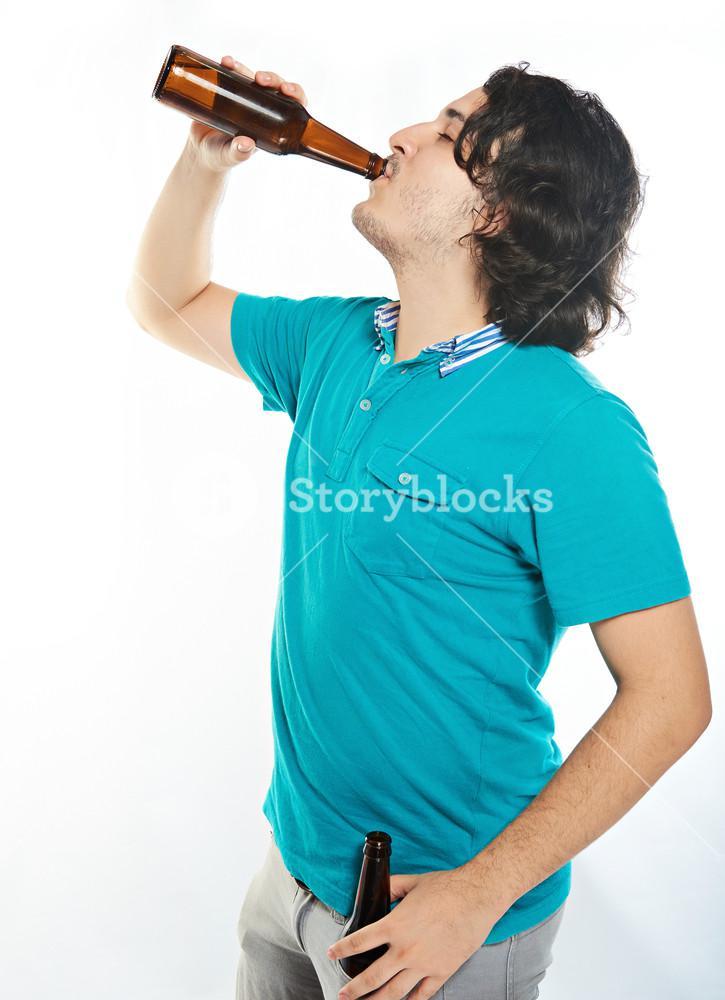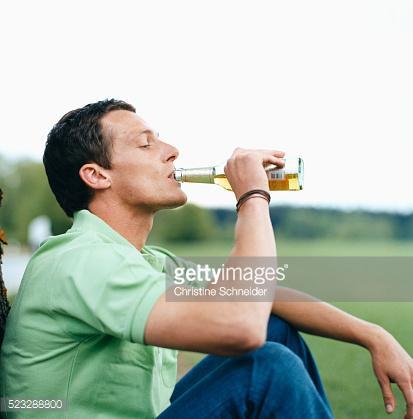The first image is the image on the left, the second image is the image on the right. Given the left and right images, does the statement "There are two guys drinking what appears to be beer." hold true? Answer yes or no. Yes. The first image is the image on the left, the second image is the image on the right. Assess this claim about the two images: "The left image shows a man leaning his head back to drink from a brown bottle held in one hand, while the other unraised hand holds another brown bottle.". Correct or not? Answer yes or no. Yes. 